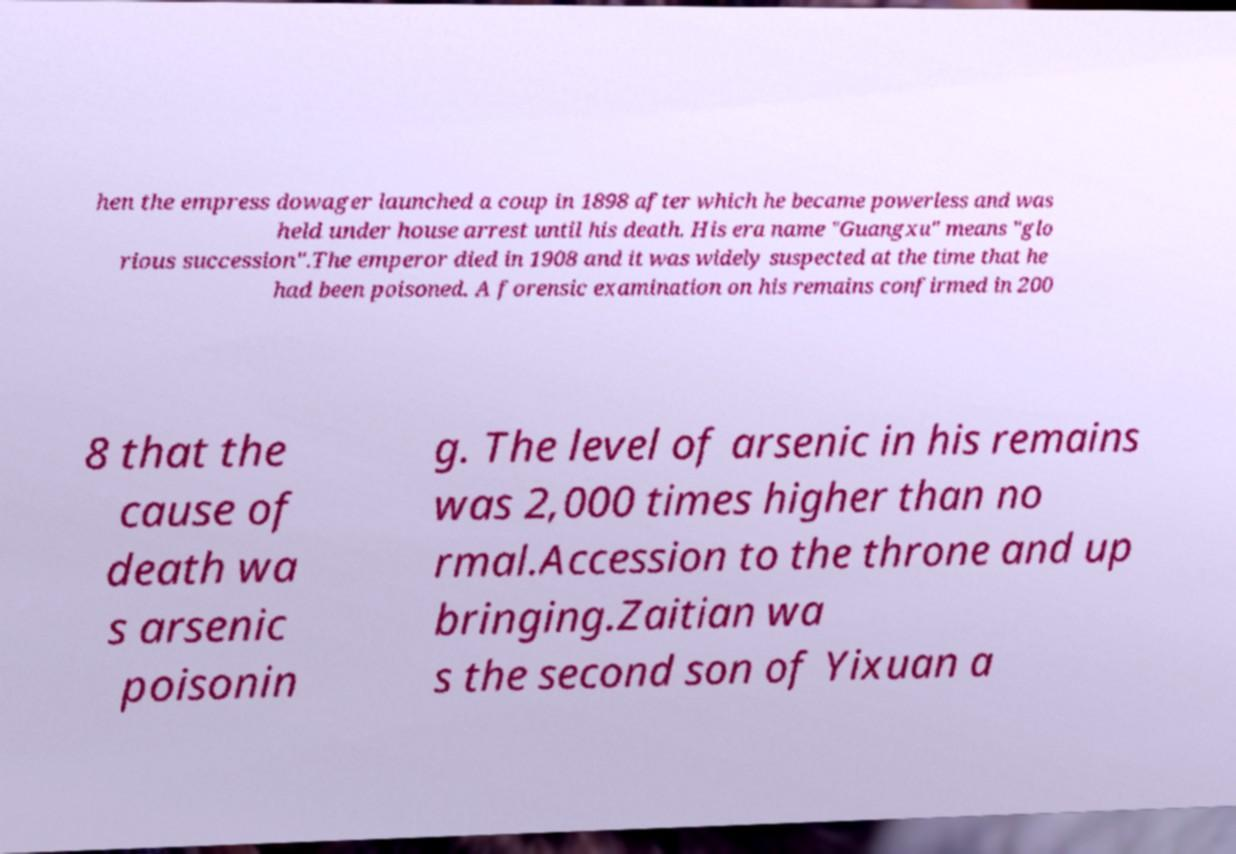What messages or text are displayed in this image? I need them in a readable, typed format. hen the empress dowager launched a coup in 1898 after which he became powerless and was held under house arrest until his death. His era name "Guangxu" means "glo rious succession".The emperor died in 1908 and it was widely suspected at the time that he had been poisoned. A forensic examination on his remains confirmed in 200 8 that the cause of death wa s arsenic poisonin g. The level of arsenic in his remains was 2,000 times higher than no rmal.Accession to the throne and up bringing.Zaitian wa s the second son of Yixuan a 